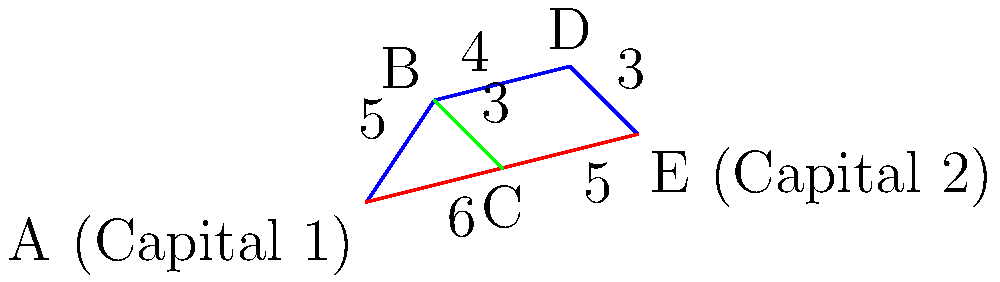As a grassroots activist advocating for improved relations between two countries, you're planning a diplomatic journey between their capitals. Given the topological map showing various routes connecting cities A (Capital 1) and E (Capital 2), what is the shortest path between these two capitals? Express your answer as a sequence of cities visited, including the starting and ending points. To find the shortest path between Capital 1 (A) and Capital 2 (E), we need to consider all possible routes and calculate their total distances:

1. Path A-B-D-E:
   Distance = 5 + 4 + 3 = 12

2. Path A-C-E:
   Distance = 6 + 5 = 11

3. Path A-B-C-E:
   Distance = 5 + 3 + 5 = 13

The shortest path is the one with the smallest total distance. In this case, it's the second option: A-C-E, with a total distance of 11 units.

This route not only represents the most efficient journey between the two capitals but also symbolizes the direct and open communication that a grassroots activist would advocate for in improving relations between the two countries.
Answer: A-C-E 